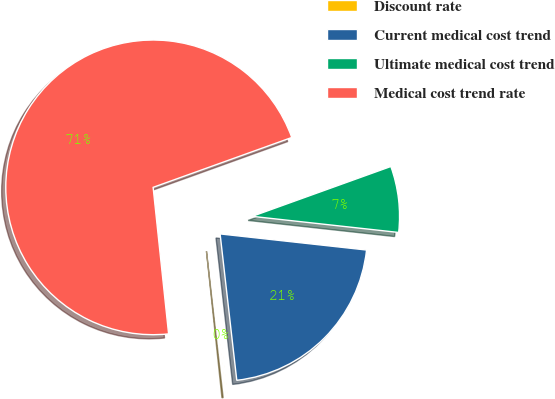<chart> <loc_0><loc_0><loc_500><loc_500><pie_chart><fcel>Discount rate<fcel>Current medical cost trend<fcel>Ultimate medical cost trend<fcel>Medical cost trend rate<nl><fcel>0.13%<fcel>21.45%<fcel>7.24%<fcel>71.18%<nl></chart> 